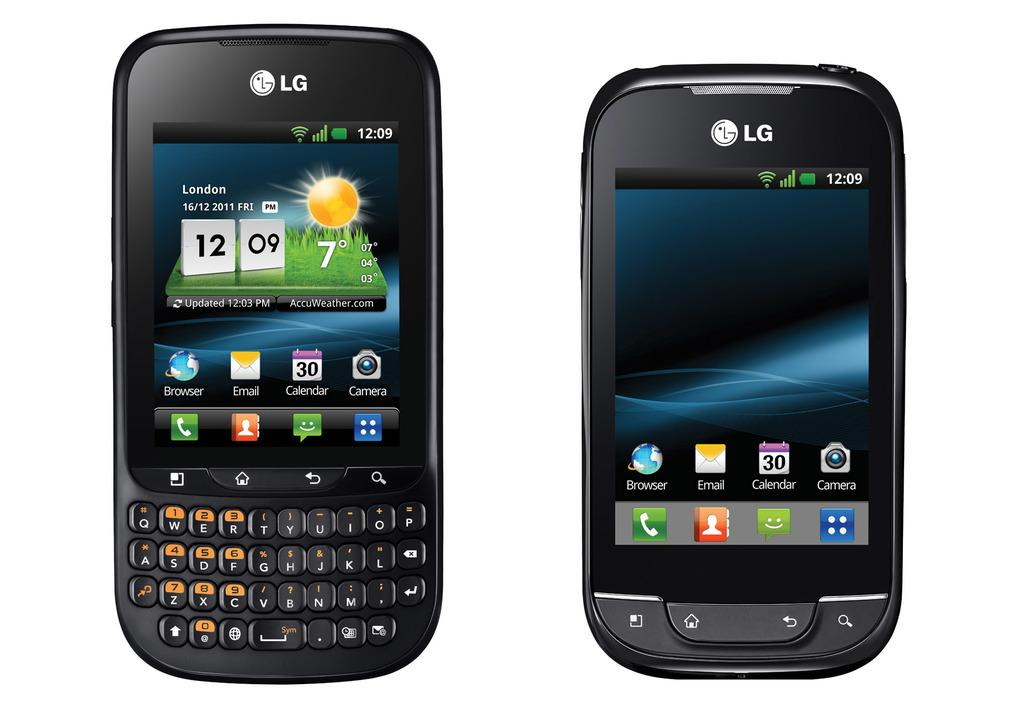<image>
Create a compact narrative representing the image presented. the front of two different LG branded smartphones 